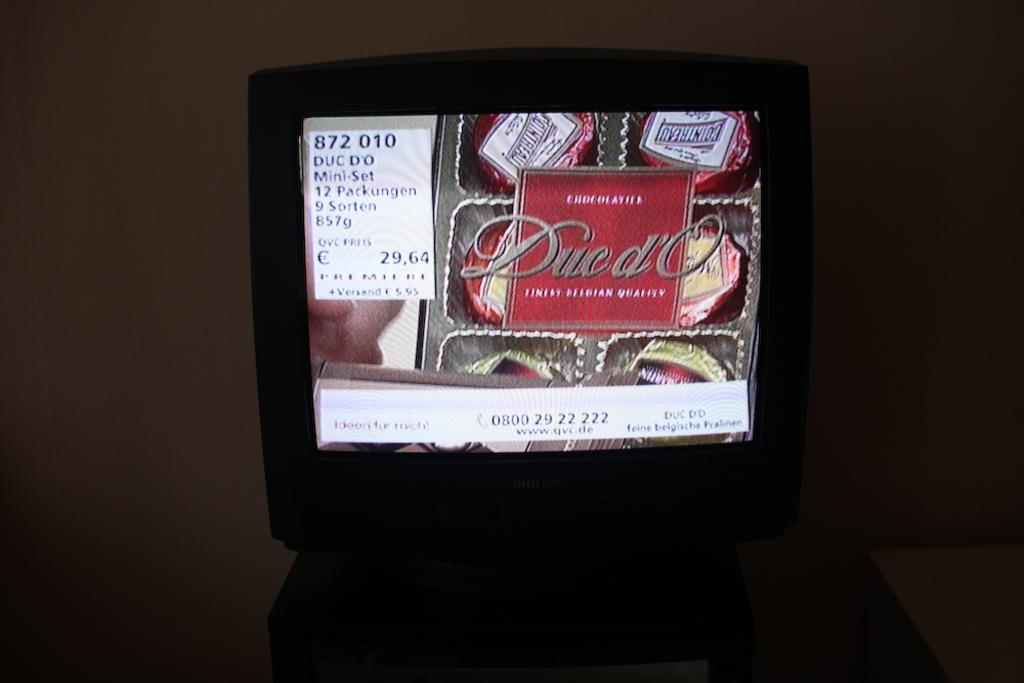What is the main object in the image? There is a television in the image. What is being shown on the television screen? Pictures of chocolates are displayed on the television screen, along with information related to chocolates. What can be seen in the background of the image? There is a wall in the background of the image. Can you see a crook walking along the ocean in the image? No, there is no crook or ocean present in the image. The image features a television displaying information about chocolates. 